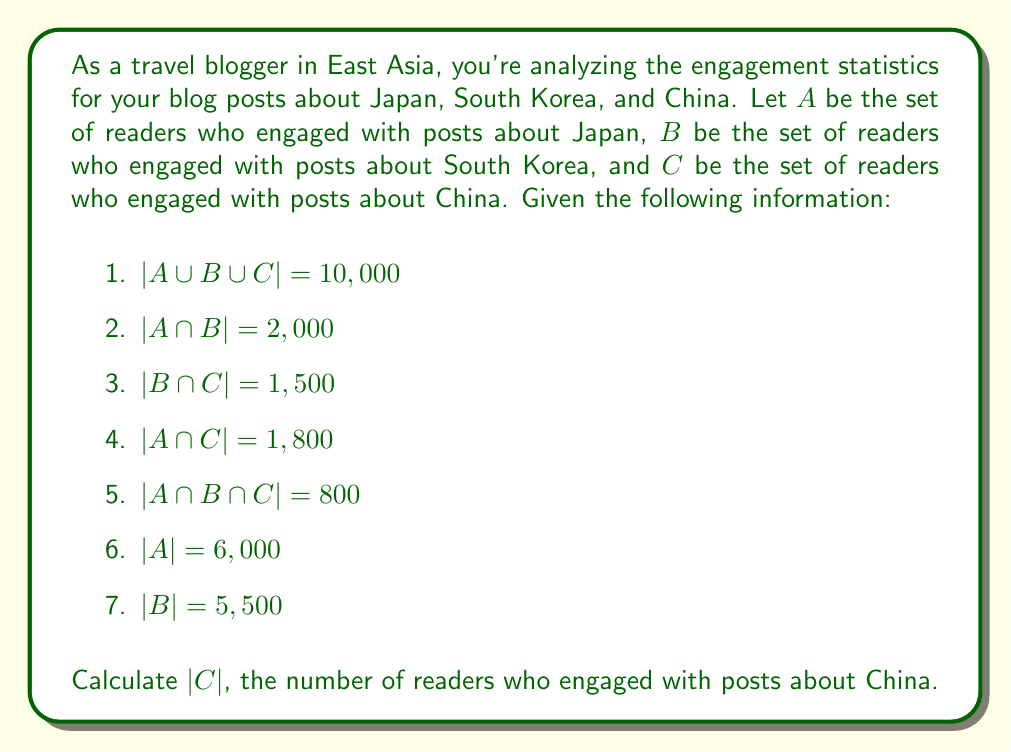Teach me how to tackle this problem. To solve this problem, we'll use the principle of inclusion-exclusion for three sets:

$$|A \cup B \cup C| = |A| + |B| + |C| - |A \cap B| - |B \cap C| - |A \cap C| + |A \cap B \cap C|$$

We're given most of these values, so let's substitute them into the equation:

$$10,000 = 6,000 + 5,500 + |C| - 2,000 - 1,500 - 1,800 + 800$$

Now, let's solve for $|C|$:

1. Combine like terms on the right side of the equation:
   $$10,000 = 11,500 + |C| - 5,300 + 800$$
   $$10,000 = 7,000 + |C|$$

2. Subtract 7,000 from both sides:
   $$3,000 = |C|$$

Therefore, the number of readers who engaged with posts about China is 3,000.
Answer: $|C| = 3,000$ 